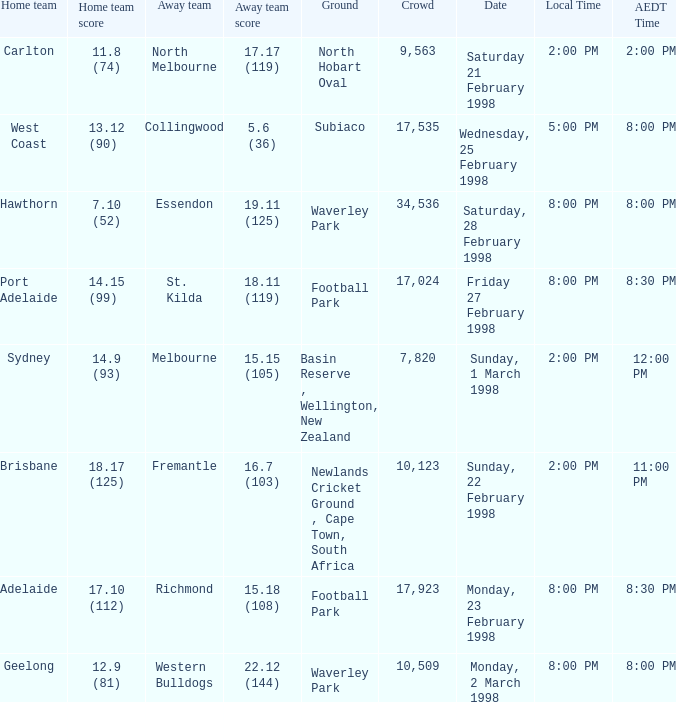Which Home team is on Wednesday, 25 february 1998? West Coast. 